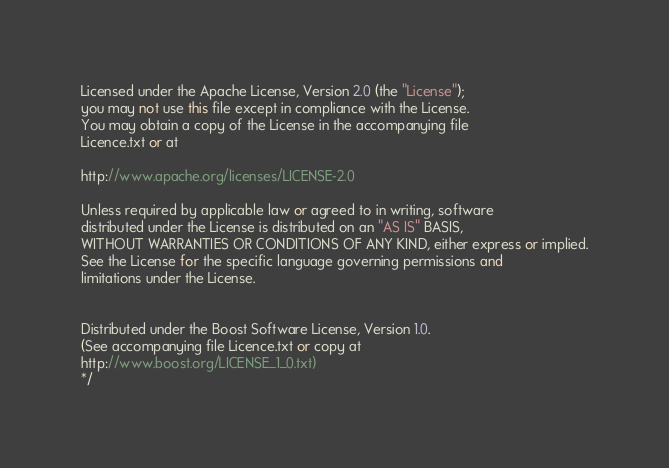Convert code to text. <code><loc_0><loc_0><loc_500><loc_500><_C++_>Licensed under the Apache License, Version 2.0 (the "License");
you may not use this file except in compliance with the License.
You may obtain a copy of the License in the accompanying file
Licence.txt or at

http://www.apache.org/licenses/LICENSE-2.0

Unless required by applicable law or agreed to in writing, software
distributed under the License is distributed on an "AS IS" BASIS,
WITHOUT WARRANTIES OR CONDITIONS OF ANY KIND, either express or implied.
See the License for the specific language governing permissions and
limitations under the License.


Distributed under the Boost Software License, Version 1.0.
(See accompanying file Licence.txt or copy at
http://www.boost.org/LICENSE_1_0.txt)
*/
</code> 